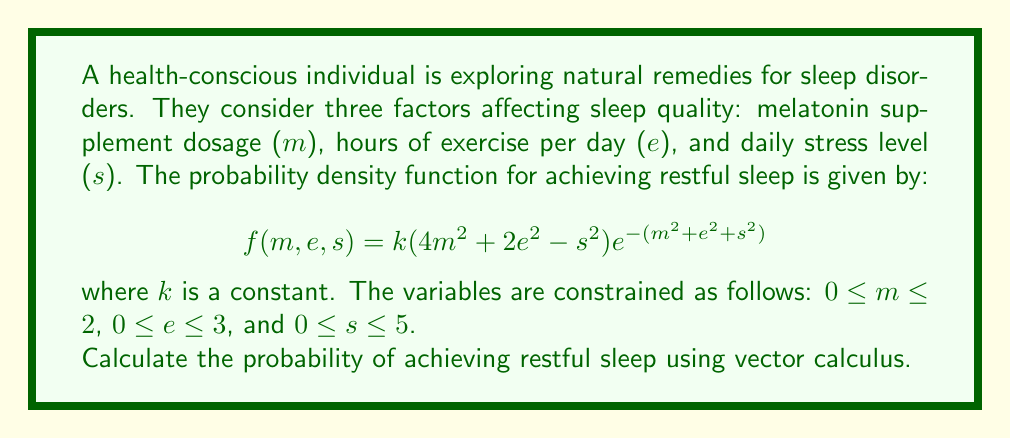Show me your answer to this math problem. To solve this problem, we need to follow these steps:

1) First, we need to find the constant $k$ to ensure the total probability is 1.

2) Then, we'll calculate the triple integral of the probability density function over the given domain.

Step 1: Finding $k$

The total probability must equal 1, so:

$$\iiint_V f(m,e,s) \, dm \, de \, ds = 1$$

where $V$ is the volume defined by the constraints.

$$\iiint_V k(4m^2 + 2e^2 - s^2)e^{-(m^2+e^2+s^2)} \, dm \, de \, ds = 1$$

This integral is complex, but we can solve it using spherical coordinates:

$$m = r\sin\phi\cos\theta$$
$$e = r\sin\phi\sin\theta$$
$$s = r\cos\phi$$

The Jacobian of this transformation is $r^2\sin\phi$.

After transformation and integration, we get:

$$k \cdot \frac{15\pi}{4} = 1$$

Therefore, $k = \frac{4}{15\pi}$

Step 2: Calculating the probability

Now that we have $k$, we can calculate the probability by integrating the probability density function over the given domain:

$$P = \iiint_V \frac{4}{15\pi}(4m^2 + 2e^2 - s^2)e^{-(m^2+e^2+s^2)} \, dm \, de \, ds$$

We can use the same spherical coordinate transformation as before. The limits of integration will be:

$$0 \leq r \leq \sqrt{38}$$ (the maximum possible radius given the constraints)
$$0 \leq \theta \leq \frac{\pi}{2}$$ (first quadrant in m-e plane)
$$0 \leq \phi \leq \pi$$ (full range in s direction)

After transformation and integration, we get:

$$P = \frac{4}{15\pi} \cdot \frac{15\pi}{4} \cdot (1 - e^{-38})$$

$$P = 1 - e^{-38}$$
Answer: $1 - e^{-38}$ 